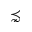Convert formula to latex. <formula><loc_0><loc_0><loc_500><loc_500>\precnsim</formula> 